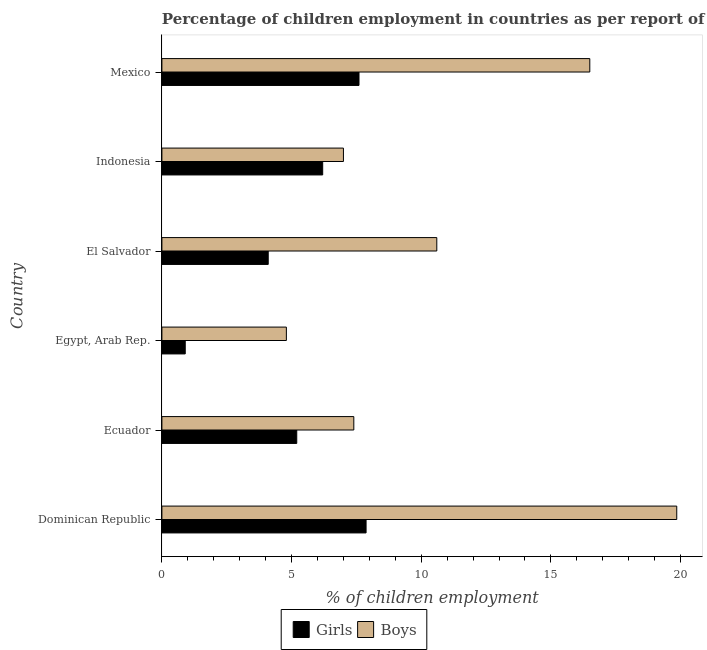How many different coloured bars are there?
Your response must be concise. 2. How many groups of bars are there?
Your answer should be very brief. 6. Are the number of bars on each tick of the Y-axis equal?
Provide a short and direct response. Yes. How many bars are there on the 6th tick from the bottom?
Keep it short and to the point. 2. What is the label of the 4th group of bars from the top?
Your answer should be very brief. Egypt, Arab Rep. In how many cases, is the number of bars for a given country not equal to the number of legend labels?
Give a very brief answer. 0. What is the percentage of employed girls in Ecuador?
Give a very brief answer. 5.2. Across all countries, what is the maximum percentage of employed boys?
Make the answer very short. 19.85. In which country was the percentage of employed girls maximum?
Offer a very short reply. Dominican Republic. In which country was the percentage of employed girls minimum?
Give a very brief answer. Egypt, Arab Rep. What is the total percentage of employed boys in the graph?
Your answer should be compact. 66.15. What is the difference between the percentage of employed boys in Dominican Republic and the percentage of employed girls in El Salvador?
Offer a very short reply. 15.75. What is the average percentage of employed boys per country?
Provide a short and direct response. 11.03. In how many countries, is the percentage of employed boys greater than 9 %?
Provide a succinct answer. 3. What is the ratio of the percentage of employed girls in Egypt, Arab Rep. to that in Mexico?
Make the answer very short. 0.12. Is the difference between the percentage of employed girls in Egypt, Arab Rep. and Mexico greater than the difference between the percentage of employed boys in Egypt, Arab Rep. and Mexico?
Provide a succinct answer. Yes. What is the difference between the highest and the second highest percentage of employed girls?
Your answer should be very brief. 0.27. What is the difference between the highest and the lowest percentage of employed girls?
Your answer should be compact. 6.97. In how many countries, is the percentage of employed boys greater than the average percentage of employed boys taken over all countries?
Keep it short and to the point. 2. Is the sum of the percentage of employed boys in Ecuador and El Salvador greater than the maximum percentage of employed girls across all countries?
Offer a terse response. Yes. What does the 2nd bar from the top in Indonesia represents?
Keep it short and to the point. Girls. What does the 2nd bar from the bottom in Egypt, Arab Rep. represents?
Keep it short and to the point. Boys. How many bars are there?
Offer a terse response. 12. Are all the bars in the graph horizontal?
Offer a terse response. Yes. How many countries are there in the graph?
Make the answer very short. 6. What is the difference between two consecutive major ticks on the X-axis?
Make the answer very short. 5. Are the values on the major ticks of X-axis written in scientific E-notation?
Offer a terse response. No. Does the graph contain grids?
Provide a short and direct response. No. How many legend labels are there?
Offer a very short reply. 2. What is the title of the graph?
Keep it short and to the point. Percentage of children employment in countries as per report of 2009. Does "Domestic Liabilities" appear as one of the legend labels in the graph?
Make the answer very short. No. What is the label or title of the X-axis?
Ensure brevity in your answer.  % of children employment. What is the % of children employment of Girls in Dominican Republic?
Keep it short and to the point. 7.87. What is the % of children employment in Boys in Dominican Republic?
Your response must be concise. 19.85. What is the % of children employment of Girls in Ecuador?
Your response must be concise. 5.2. What is the % of children employment in Girls in Egypt, Arab Rep.?
Your answer should be compact. 0.9. What is the % of children employment of Girls in El Salvador?
Your answer should be very brief. 4.1. What is the % of children employment in Girls in Indonesia?
Provide a short and direct response. 6.2. What is the % of children employment in Girls in Mexico?
Your answer should be compact. 7.6. What is the % of children employment in Boys in Mexico?
Your answer should be compact. 16.5. Across all countries, what is the maximum % of children employment of Girls?
Keep it short and to the point. 7.87. Across all countries, what is the maximum % of children employment in Boys?
Keep it short and to the point. 19.85. Across all countries, what is the minimum % of children employment in Girls?
Make the answer very short. 0.9. What is the total % of children employment in Girls in the graph?
Provide a short and direct response. 31.87. What is the total % of children employment of Boys in the graph?
Your answer should be compact. 66.15. What is the difference between the % of children employment in Girls in Dominican Republic and that in Ecuador?
Provide a succinct answer. 2.67. What is the difference between the % of children employment of Boys in Dominican Republic and that in Ecuador?
Give a very brief answer. 12.45. What is the difference between the % of children employment in Girls in Dominican Republic and that in Egypt, Arab Rep.?
Your answer should be very brief. 6.97. What is the difference between the % of children employment of Boys in Dominican Republic and that in Egypt, Arab Rep.?
Provide a short and direct response. 15.05. What is the difference between the % of children employment of Girls in Dominican Republic and that in El Salvador?
Offer a very short reply. 3.77. What is the difference between the % of children employment in Boys in Dominican Republic and that in El Salvador?
Your answer should be compact. 9.25. What is the difference between the % of children employment of Girls in Dominican Republic and that in Indonesia?
Offer a terse response. 1.67. What is the difference between the % of children employment in Boys in Dominican Republic and that in Indonesia?
Ensure brevity in your answer.  12.85. What is the difference between the % of children employment of Girls in Dominican Republic and that in Mexico?
Provide a short and direct response. 0.27. What is the difference between the % of children employment in Boys in Dominican Republic and that in Mexico?
Your response must be concise. 3.35. What is the difference between the % of children employment in Boys in Ecuador and that in Egypt, Arab Rep.?
Your answer should be very brief. 2.6. What is the difference between the % of children employment of Boys in Ecuador and that in El Salvador?
Provide a short and direct response. -3.2. What is the difference between the % of children employment in Boys in Ecuador and that in Indonesia?
Your answer should be compact. 0.4. What is the difference between the % of children employment of Girls in Ecuador and that in Mexico?
Keep it short and to the point. -2.4. What is the difference between the % of children employment of Boys in Egypt, Arab Rep. and that in El Salvador?
Give a very brief answer. -5.8. What is the difference between the % of children employment of Girls in Egypt, Arab Rep. and that in Indonesia?
Your response must be concise. -5.3. What is the difference between the % of children employment in Girls in Egypt, Arab Rep. and that in Mexico?
Your answer should be compact. -6.7. What is the difference between the % of children employment in Boys in Egypt, Arab Rep. and that in Mexico?
Make the answer very short. -11.7. What is the difference between the % of children employment in Girls in El Salvador and that in Indonesia?
Your response must be concise. -2.1. What is the difference between the % of children employment of Boys in El Salvador and that in Indonesia?
Offer a very short reply. 3.6. What is the difference between the % of children employment of Girls in El Salvador and that in Mexico?
Your answer should be very brief. -3.5. What is the difference between the % of children employment of Boys in El Salvador and that in Mexico?
Provide a succinct answer. -5.9. What is the difference between the % of children employment in Boys in Indonesia and that in Mexico?
Provide a short and direct response. -9.5. What is the difference between the % of children employment of Girls in Dominican Republic and the % of children employment of Boys in Ecuador?
Your answer should be compact. 0.47. What is the difference between the % of children employment of Girls in Dominican Republic and the % of children employment of Boys in Egypt, Arab Rep.?
Give a very brief answer. 3.07. What is the difference between the % of children employment in Girls in Dominican Republic and the % of children employment in Boys in El Salvador?
Ensure brevity in your answer.  -2.73. What is the difference between the % of children employment of Girls in Dominican Republic and the % of children employment of Boys in Indonesia?
Your answer should be compact. 0.87. What is the difference between the % of children employment in Girls in Dominican Republic and the % of children employment in Boys in Mexico?
Ensure brevity in your answer.  -8.63. What is the difference between the % of children employment in Girls in Ecuador and the % of children employment in Boys in Egypt, Arab Rep.?
Keep it short and to the point. 0.4. What is the difference between the % of children employment of Girls in Ecuador and the % of children employment of Boys in El Salvador?
Offer a very short reply. -5.4. What is the difference between the % of children employment in Girls in Egypt, Arab Rep. and the % of children employment in Boys in El Salvador?
Your answer should be very brief. -9.7. What is the difference between the % of children employment of Girls in Egypt, Arab Rep. and the % of children employment of Boys in Mexico?
Offer a very short reply. -15.6. What is the average % of children employment of Girls per country?
Offer a terse response. 5.31. What is the average % of children employment of Boys per country?
Provide a short and direct response. 11.03. What is the difference between the % of children employment in Girls and % of children employment in Boys in Dominican Republic?
Offer a terse response. -11.98. What is the difference between the % of children employment of Girls and % of children employment of Boys in Egypt, Arab Rep.?
Your answer should be compact. -3.9. What is the ratio of the % of children employment in Girls in Dominican Republic to that in Ecuador?
Ensure brevity in your answer.  1.51. What is the ratio of the % of children employment in Boys in Dominican Republic to that in Ecuador?
Ensure brevity in your answer.  2.68. What is the ratio of the % of children employment in Girls in Dominican Republic to that in Egypt, Arab Rep.?
Your answer should be very brief. 8.75. What is the ratio of the % of children employment of Boys in Dominican Republic to that in Egypt, Arab Rep.?
Your answer should be compact. 4.14. What is the ratio of the % of children employment in Girls in Dominican Republic to that in El Salvador?
Offer a very short reply. 1.92. What is the ratio of the % of children employment in Boys in Dominican Republic to that in El Salvador?
Offer a terse response. 1.87. What is the ratio of the % of children employment in Girls in Dominican Republic to that in Indonesia?
Provide a succinct answer. 1.27. What is the ratio of the % of children employment in Boys in Dominican Republic to that in Indonesia?
Offer a terse response. 2.84. What is the ratio of the % of children employment of Girls in Dominican Republic to that in Mexico?
Keep it short and to the point. 1.04. What is the ratio of the % of children employment in Boys in Dominican Republic to that in Mexico?
Your answer should be very brief. 1.2. What is the ratio of the % of children employment in Girls in Ecuador to that in Egypt, Arab Rep.?
Offer a very short reply. 5.78. What is the ratio of the % of children employment in Boys in Ecuador to that in Egypt, Arab Rep.?
Provide a short and direct response. 1.54. What is the ratio of the % of children employment in Girls in Ecuador to that in El Salvador?
Keep it short and to the point. 1.27. What is the ratio of the % of children employment of Boys in Ecuador to that in El Salvador?
Your response must be concise. 0.7. What is the ratio of the % of children employment in Girls in Ecuador to that in Indonesia?
Provide a short and direct response. 0.84. What is the ratio of the % of children employment of Boys in Ecuador to that in Indonesia?
Your answer should be compact. 1.06. What is the ratio of the % of children employment in Girls in Ecuador to that in Mexico?
Provide a succinct answer. 0.68. What is the ratio of the % of children employment of Boys in Ecuador to that in Mexico?
Your answer should be compact. 0.45. What is the ratio of the % of children employment of Girls in Egypt, Arab Rep. to that in El Salvador?
Ensure brevity in your answer.  0.22. What is the ratio of the % of children employment of Boys in Egypt, Arab Rep. to that in El Salvador?
Provide a short and direct response. 0.45. What is the ratio of the % of children employment of Girls in Egypt, Arab Rep. to that in Indonesia?
Ensure brevity in your answer.  0.15. What is the ratio of the % of children employment of Boys in Egypt, Arab Rep. to that in Indonesia?
Offer a very short reply. 0.69. What is the ratio of the % of children employment of Girls in Egypt, Arab Rep. to that in Mexico?
Your answer should be very brief. 0.12. What is the ratio of the % of children employment in Boys in Egypt, Arab Rep. to that in Mexico?
Offer a very short reply. 0.29. What is the ratio of the % of children employment in Girls in El Salvador to that in Indonesia?
Keep it short and to the point. 0.66. What is the ratio of the % of children employment of Boys in El Salvador to that in Indonesia?
Provide a short and direct response. 1.51. What is the ratio of the % of children employment of Girls in El Salvador to that in Mexico?
Give a very brief answer. 0.54. What is the ratio of the % of children employment in Boys in El Salvador to that in Mexico?
Give a very brief answer. 0.64. What is the ratio of the % of children employment in Girls in Indonesia to that in Mexico?
Keep it short and to the point. 0.82. What is the ratio of the % of children employment in Boys in Indonesia to that in Mexico?
Your answer should be compact. 0.42. What is the difference between the highest and the second highest % of children employment in Girls?
Offer a terse response. 0.27. What is the difference between the highest and the second highest % of children employment of Boys?
Give a very brief answer. 3.35. What is the difference between the highest and the lowest % of children employment of Girls?
Your answer should be very brief. 6.97. What is the difference between the highest and the lowest % of children employment in Boys?
Your answer should be very brief. 15.05. 